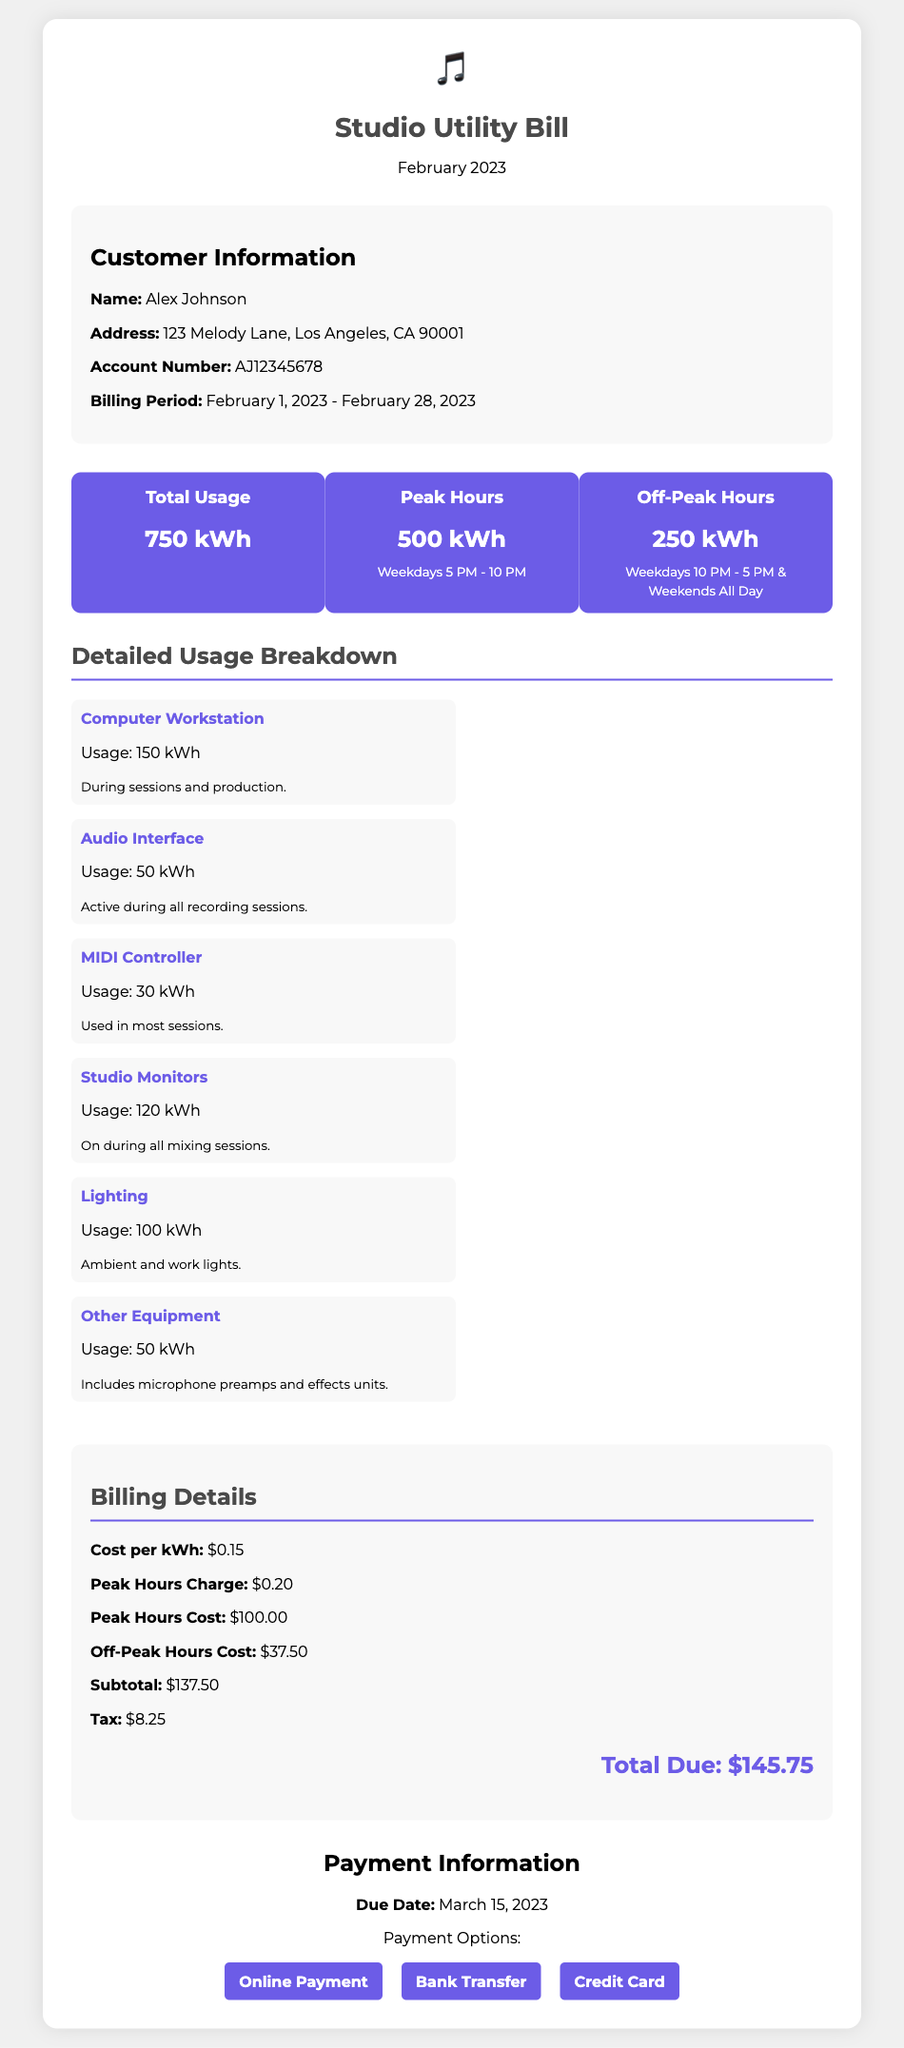What is the total electricity usage? The total electricity usage for the studio during February 2023 is specifically stated in the document.
Answer: 750 kWh What is the peak hours charge per kWh? The document clearly specifies the rate charged during peak hours per kilowatt-hour.
Answer: $0.20 What was the total cost for peak hours? The total cost for usage during peak hours is calculated and presented in the bill.
Answer: $100.00 Who is the customer? The document includes the name of the individual to whom the bill is addressed.
Answer: Alex Johnson What is the due date for the payment? The due date for the payment is explicitly mentioned in the payment information section of the document.
Answer: March 15, 2023 How much tax was applied to the subtotal? The document indicates the amount of tax added to the subtotal for this bill.
Answer: $8.25 What percentage of total usage was during peak hours? To find this percentage, the peak hours usage is divided by total usage: (500 kWh / 750 kWh) * 100, as stated in the document.
Answer: 66.67% What is the address of the studio? The studio's address is part of the customer information provided in the document.
Answer: 123 Melody Lane, Los Angeles, CA 90001 What was the total amount due? The total due is calculated at the end of the billing details and is summarized in the document.
Answer: $145.75 